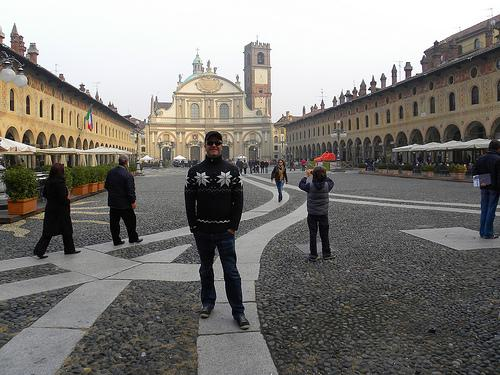What is the predominant color of the street in the image? The street is predominantly dark gray. Please describe the ground in the image. The ground is covered in a gravel pavement with designs and it is painted, paved, and made of concrete in different shades of gray. Mention a tourist in the picture and what they are wearing. A man dressed in a grey puffer vest, black pants, and sunglasses acts as a tourist. Is there any woman in the image? If yes, describe her clothing. Yes, there is a woman walking, wearing a long black coat and black pants. What kind of buildings can you see in the image? There are old buildings and a large yellow stone church at the end of the square. Identify the type of area depicted in the image. The image depicts an urban area with old buildings and a street. Discuss a specific architectural element that stands out in the image. The large yellow stone church at the end of the square is a notable architectural element. What type of light is present in the image? There is a double globe light in the image. Can you describe the clothing of the man posing in the image? The man is wearing a black sweater with white snowflakes, dark blue jeans, black chucks, and sunglasses. What emotions can you sense from the image and its elements? The image conveys a lively, busy, and urban atmosphere, with people walking around and old, historic architecture. In what type of coat is the woman walking? Long black coat In what type of attire is the man walking in black suit? Formal attire Where is the double globe light located? In the top left corner of the image. What color are the old buildings shown in the image? Brown Are the lines on the street bright green? This is misleading because the lines mentioned in the image are actually white, not bright green. This creates confusion by contradicting the existing image information. Describe the interaction between the man wearing black chucks and the woman wearing black pants. There is no direct interaction between them. What is the color of the lines painted on the ground? White What type of area is depicted in the image? Urban area Where is the woman wearing a long black coat located? Left side of the image, walking on the pavement. How does the tourist appear to be dressed? Wearing dark clothing and sunglasses. What color is the pavement on which the man in a sweater is standing? Light gray Identify the location of the man with the snowflake sweater. Left-middle area of the image, standing on the pavement. Is the man in grey puffer vest walking or standing? Walking What kind of ground is seen in the image? Gravel covered, paved, and concrete. Is the pavement covered in red flowers? This is misleading because the image only mentions gravel-covered pavement and various gray colors related to the pavement. There is no mention of any flowers or any red elements within the image. What design can be found on the man's sweater who posed for the image? Answer: Is there a large blue boat in the background? This is misleading because there is no mention of a boat anywhere in the image. The image focuses on the street, urban area, and people within it, not on the background or any potential water scenes. Which building is the largest in the image? The large yellow stone church at the end of the square. Does the woman walking have a pink hat on? This is misleading because there is no mention of a woman wearing a hat anywhere in the image. The woman is only mentioned as walking in a long black coat and wearing black pants. Name an emotion that may be experienced by someone posing for a photograph. Happiness or pride Is there a man dressed in a grey puffer vest and black pants? Yes How would you describe the item found in the top-left corner of the image? A double globe light How might you describe the clothing of the man wearing sunglasses? Black sweater with white snowflakes, dark blue jeans, and black chucks. Is the man wearing a bright red shirt? This is misleading because the man in the image is actually wearing a black sweater with white snowflakes, and there is no mention of a bright red shirt anywhere in the image. Locate the woman wearing black pants. Bottom left of the image, walking on the pavement. Is there a man standing on top of the yellow stone church? This is misleading because there is no mention of a man standing on any buildings within the image. The man in the image is only described as posing and wearing clothes on the street, not on any structures. 